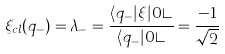Convert formula to latex. <formula><loc_0><loc_0><loc_500><loc_500>\xi _ { c l } ( q _ { - } ) = \lambda _ { - } = \frac { \langle q _ { - } | \xi | 0 \rangle } { \langle q _ { - } | 0 \rangle } = \frac { - 1 } { \sqrt { 2 } }</formula> 